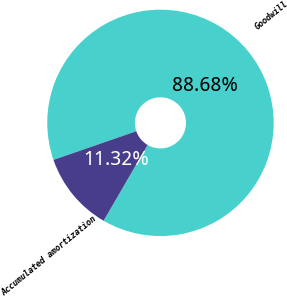Convert chart to OTSL. <chart><loc_0><loc_0><loc_500><loc_500><pie_chart><fcel>Goodwill<fcel>Accumulated amortization<nl><fcel>88.68%<fcel>11.32%<nl></chart> 